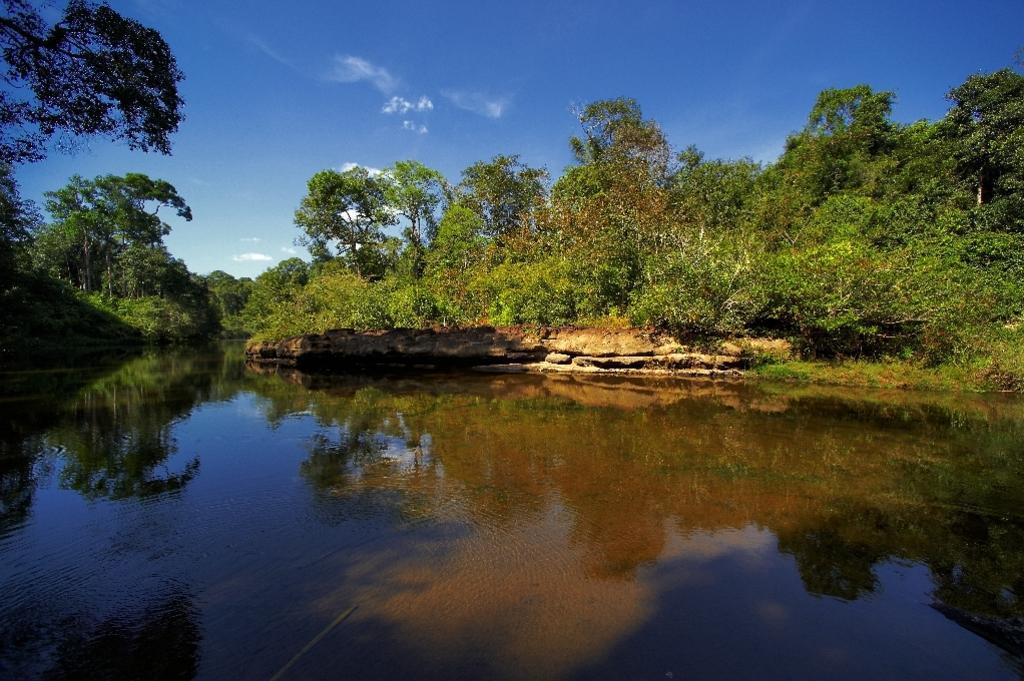Please provide a concise description of this image. There is a river and around the river there are plenty of trees and in the background there is a sky. 